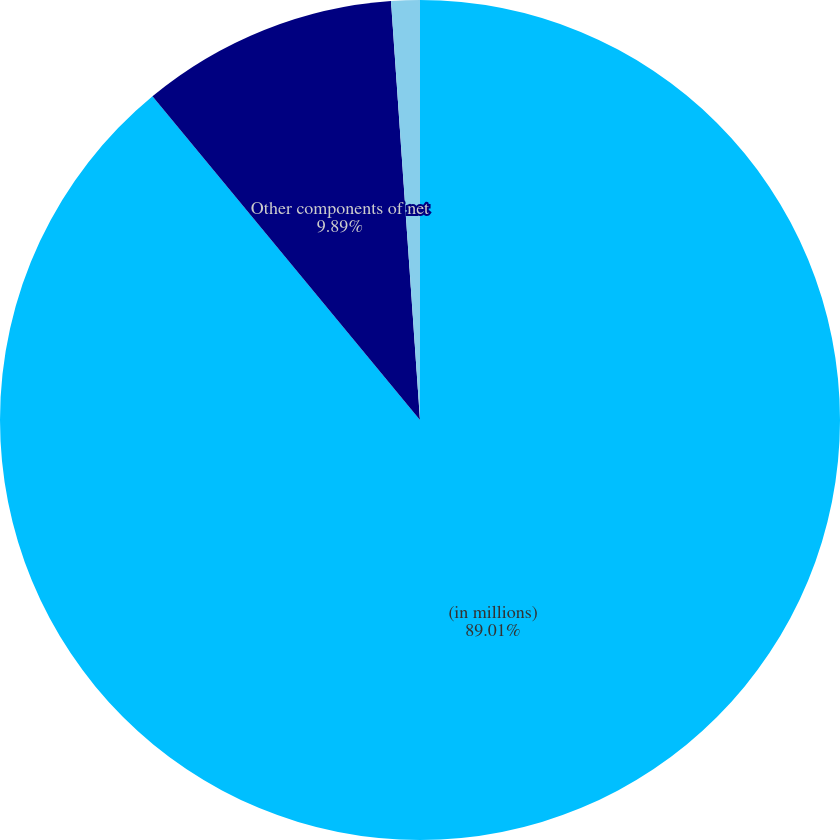Convert chart to OTSL. <chart><loc_0><loc_0><loc_500><loc_500><pie_chart><fcel>(in millions)<fcel>Other components of net<fcel>Other income net<nl><fcel>89.0%<fcel>9.89%<fcel>1.1%<nl></chart> 